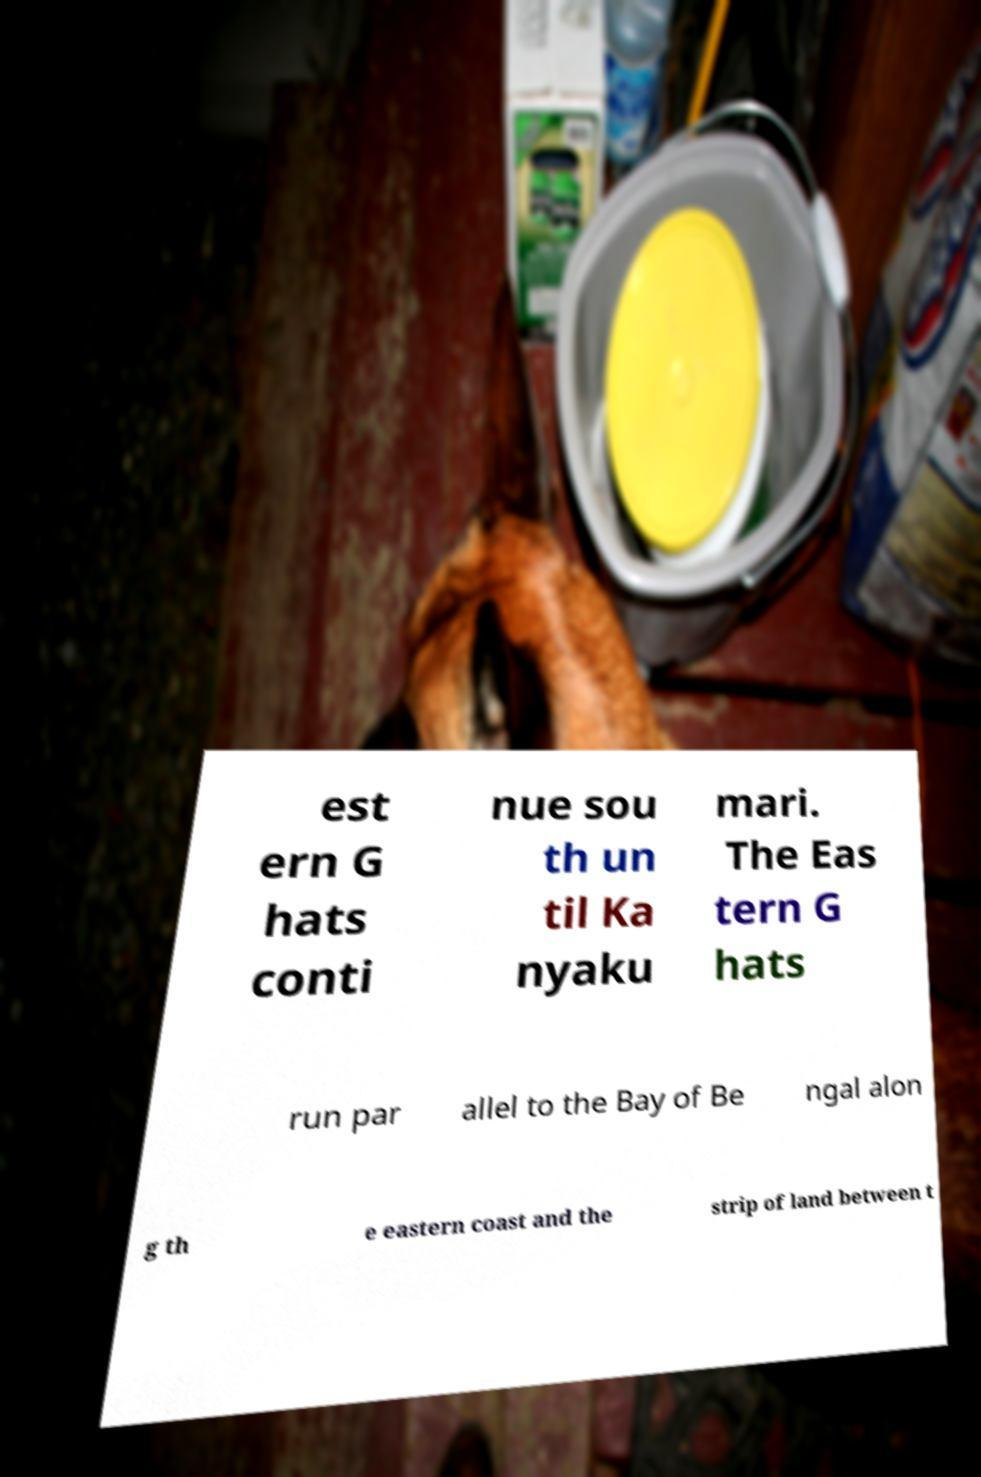Can you accurately transcribe the text from the provided image for me? est ern G hats conti nue sou th un til Ka nyaku mari. The Eas tern G hats run par allel to the Bay of Be ngal alon g th e eastern coast and the strip of land between t 